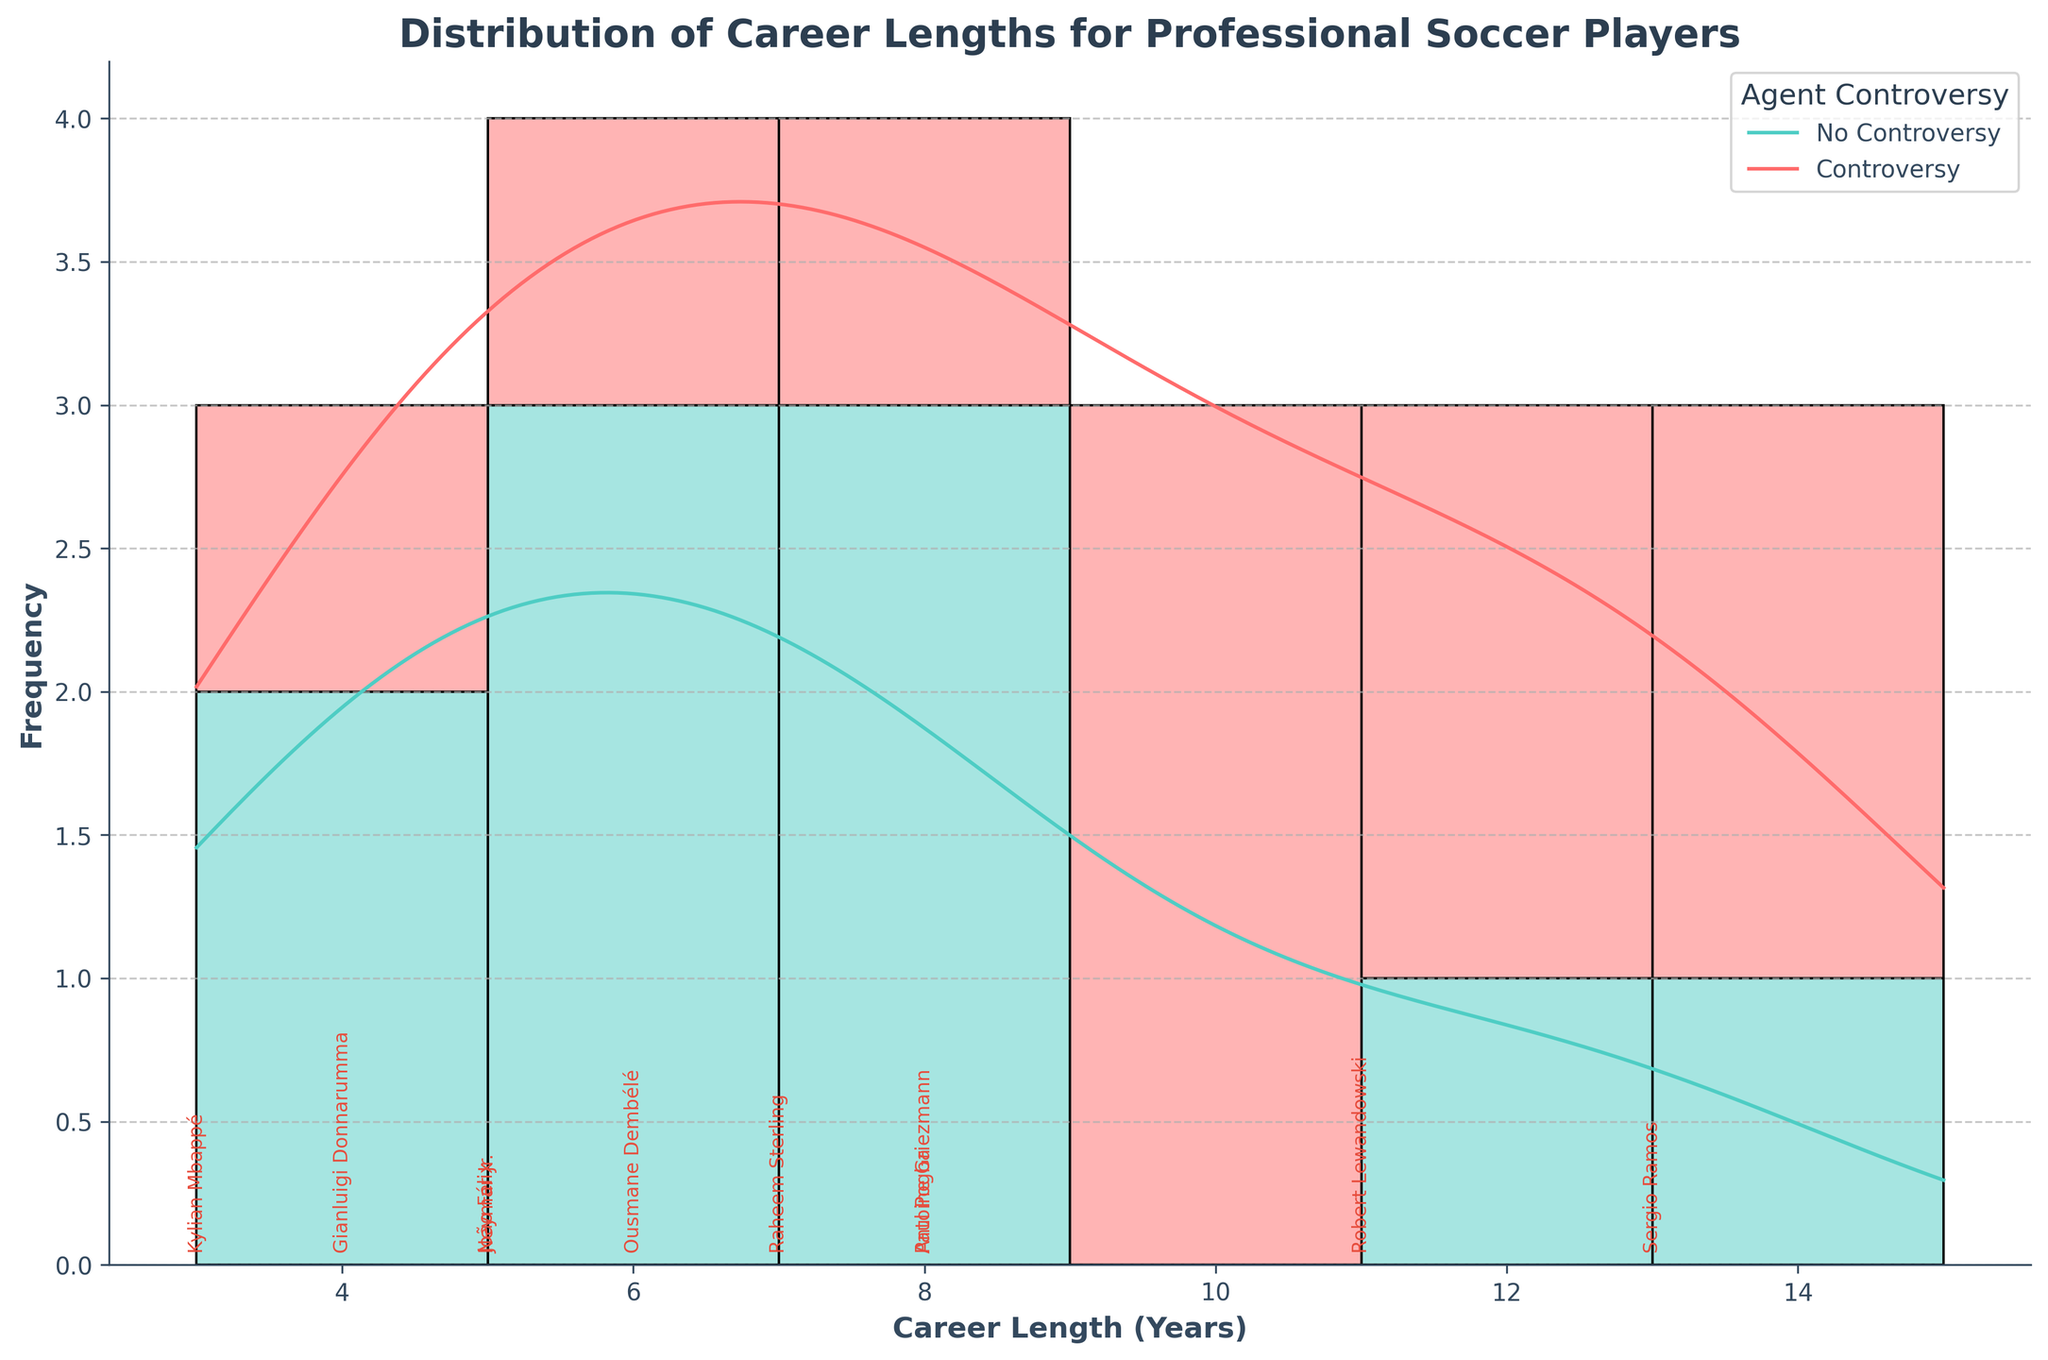What is the title of the figure? The title is usually located at the top of the figure and gives an overview of what the figure is about. Here, it shows "Distribution of Career Lengths for Professional Soccer Players," which indicates the subject and focus of the data being presented.
Answer: Distribution of Career Lengths for Professional Soccer Players How many players experienced agent-related controversies? To answer this, you can count the number of annotations colored in red (indicating agent controversy) in the figure.
Answer: 10 What is the most common career length among players without agent controversies? By examining the height of the bar (representing frequency) and the KDE peak for the segments without controversy in a specific color (No controversy, usually green), you can identify where the histogram and density curve peak the highest.
Answer: 12 years Which player with agent controversy has the shortest career length? By looking at the red annotations at the lowest end of the x-axis, you can find the earliest career lengths and their corresponding player names.
Answer: Kylian Mbappé Among the players with agent controversies, which career length appears most frequently? Observing the tallest red bars (indicating agent controversy) in the histogram will show the most frequent career length for these players.
Answer: 7 and 8 years How does the KDE (density curve) for players with controversies compare to those without for longer career lengths (e.g., over 10 years)? Examine the KDE curves to see if the density for players with controversies decreases slower, faster, or aligns with those without controversies for career lengths greater than 10 years.
Answer: The density for players with controversies generally decreases faster Which is the longest career length observed in the figure and who holds it? Look at the names annotated at the far right of the x-axis to identify the highest career length and the player's name.
Answer: Lionel Messi (15 years) For career lengths of exactly 8 years, how does the number of players with controversies compare to those without? Count the number of 8-year bars colored for agent controversy and without controversy by looking at the respective stacked bar heights at x=8.
Answer: More players with controversies Comparing career lengths of 4 years, how many players with agent controversies are there compared to those without? Look at the bar height at x=4 and check the counts of each segment indicating agent controversy and no controversy.
Answer: More players with controversies 